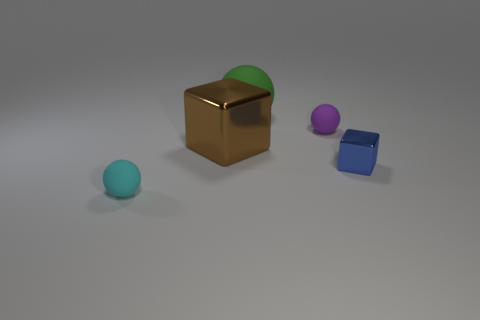Add 4 big green cubes. How many objects exist? 9 Subtract all balls. How many objects are left? 2 Add 2 large brown shiny blocks. How many large brown shiny blocks exist? 3 Subtract 1 cyan spheres. How many objects are left? 4 Subtract all yellow matte objects. Subtract all blocks. How many objects are left? 3 Add 4 brown shiny objects. How many brown shiny objects are left? 5 